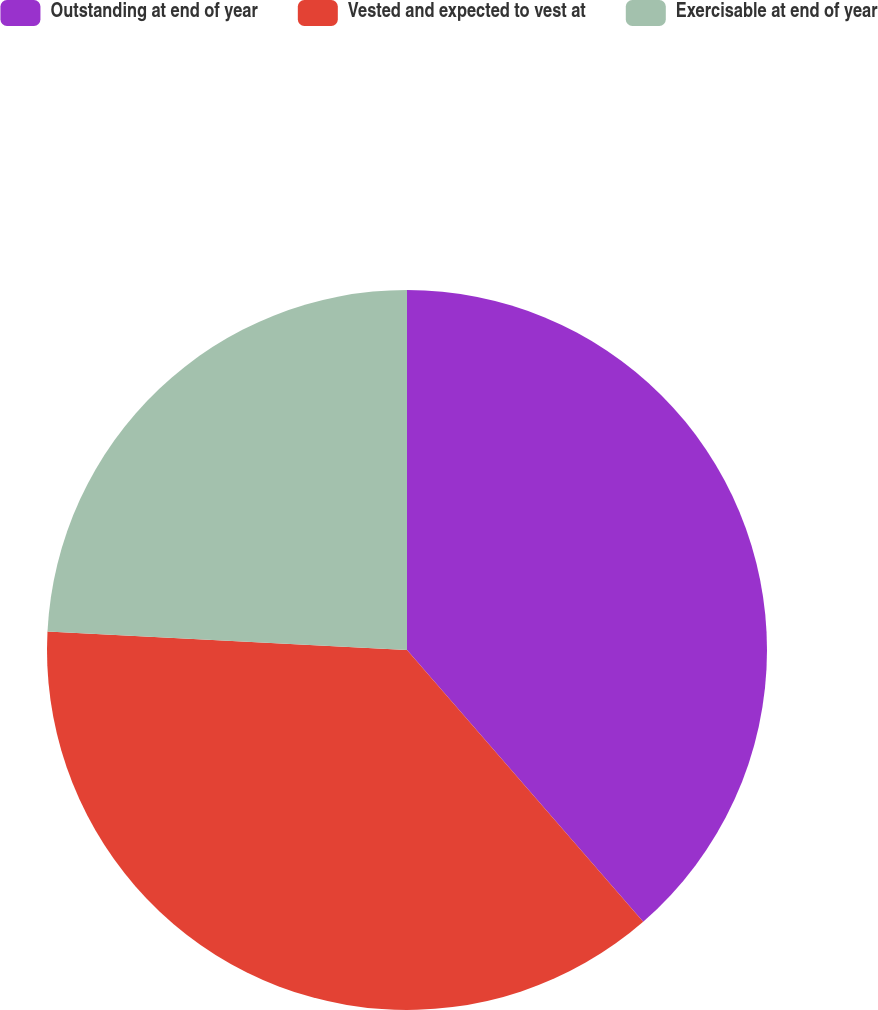<chart> <loc_0><loc_0><loc_500><loc_500><pie_chart><fcel>Outstanding at end of year<fcel>Vested and expected to vest at<fcel>Exercisable at end of year<nl><fcel>38.61%<fcel>37.21%<fcel>24.18%<nl></chart> 